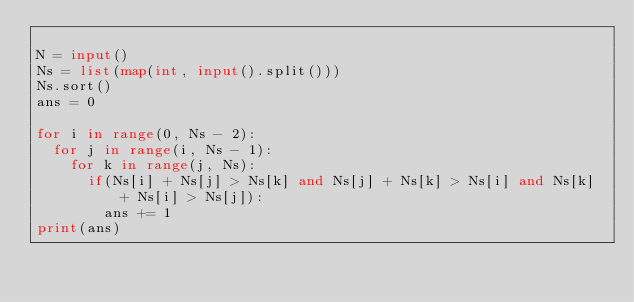<code> <loc_0><loc_0><loc_500><loc_500><_Python_>
N = input()
Ns = list(map(int, input().split()))
Ns.sort()
ans = 0

for i in range(0, Ns - 2):
	for j in range(i, Ns - 1):
		for k in range(j, Ns):
			if(Ns[i] + Ns[j] > Ns[k] and Ns[j] + Ns[k] > Ns[i] and Ns[k] + Ns[i] > Ns[j]):
				ans += 1
print(ans)</code> 